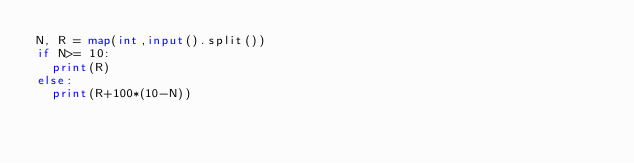<code> <loc_0><loc_0><loc_500><loc_500><_Python_>N, R = map(int,input().split())
if N>= 10:
  print(R)
else:
  print(R+100*(10-N))</code> 